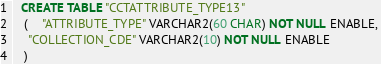<code> <loc_0><loc_0><loc_500><loc_500><_SQL_>
  CREATE TABLE "CCTATTRIBUTE_TYPE13" 
   (	"ATTRIBUTE_TYPE" VARCHAR2(60 CHAR) NOT NULL ENABLE, 
	"COLLECTION_CDE" VARCHAR2(10) NOT NULL ENABLE
   ) </code> 